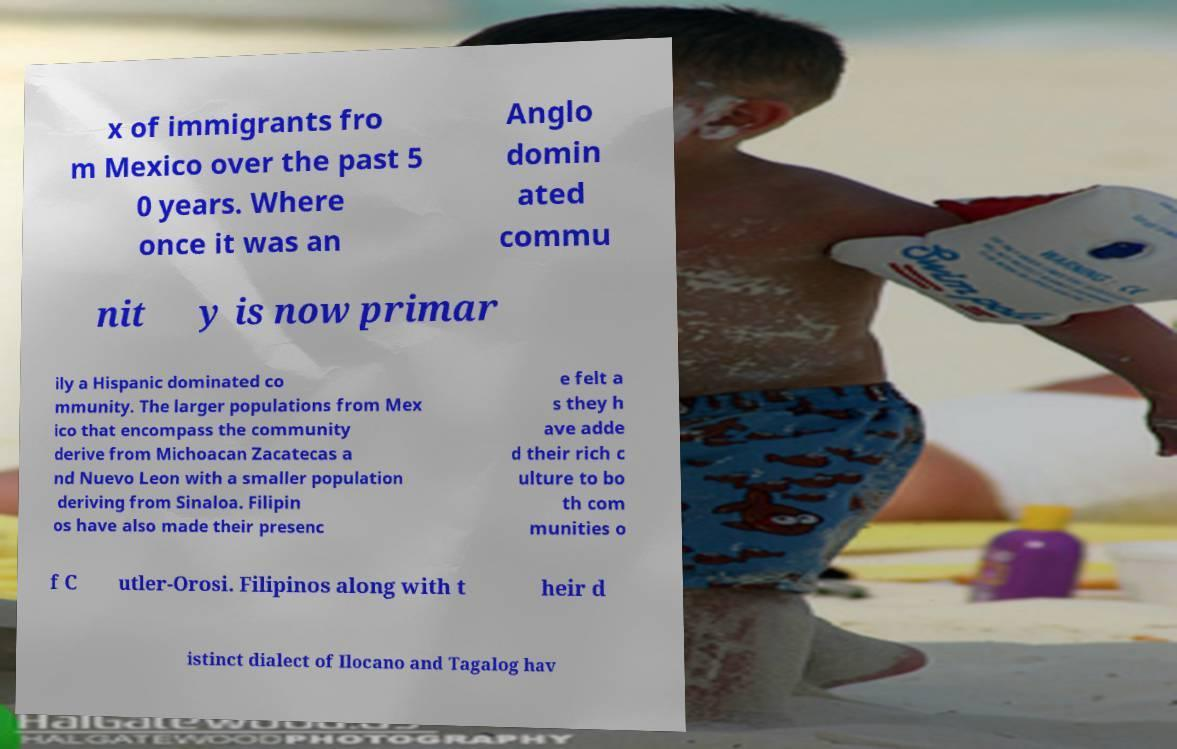Could you assist in decoding the text presented in this image and type it out clearly? x of immigrants fro m Mexico over the past 5 0 years. Where once it was an Anglo domin ated commu nit y is now primar ily a Hispanic dominated co mmunity. The larger populations from Mex ico that encompass the community derive from Michoacan Zacatecas a nd Nuevo Leon with a smaller population deriving from Sinaloa. Filipin os have also made their presenc e felt a s they h ave adde d their rich c ulture to bo th com munities o f C utler-Orosi. Filipinos along with t heir d istinct dialect of Ilocano and Tagalog hav 